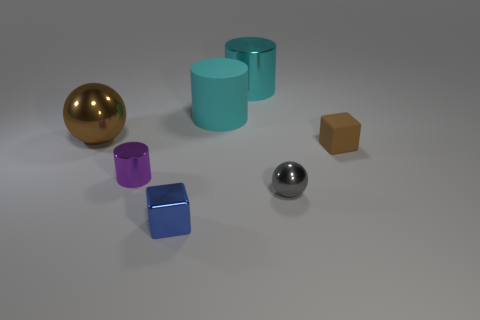Subtract all matte cylinders. How many cylinders are left? 2 Add 3 blue cubes. How many objects exist? 10 Subtract all brown spheres. How many spheres are left? 1 Subtract all gray balls. How many cyan cylinders are left? 2 Subtract all cylinders. How many objects are left? 4 Subtract all yellow blocks. Subtract all purple spheres. How many blocks are left? 2 Subtract all cyan matte cylinders. Subtract all big cyan metal objects. How many objects are left? 5 Add 5 brown matte cubes. How many brown matte cubes are left? 6 Add 7 tiny shiny cylinders. How many tiny shiny cylinders exist? 8 Subtract 0 yellow cylinders. How many objects are left? 7 